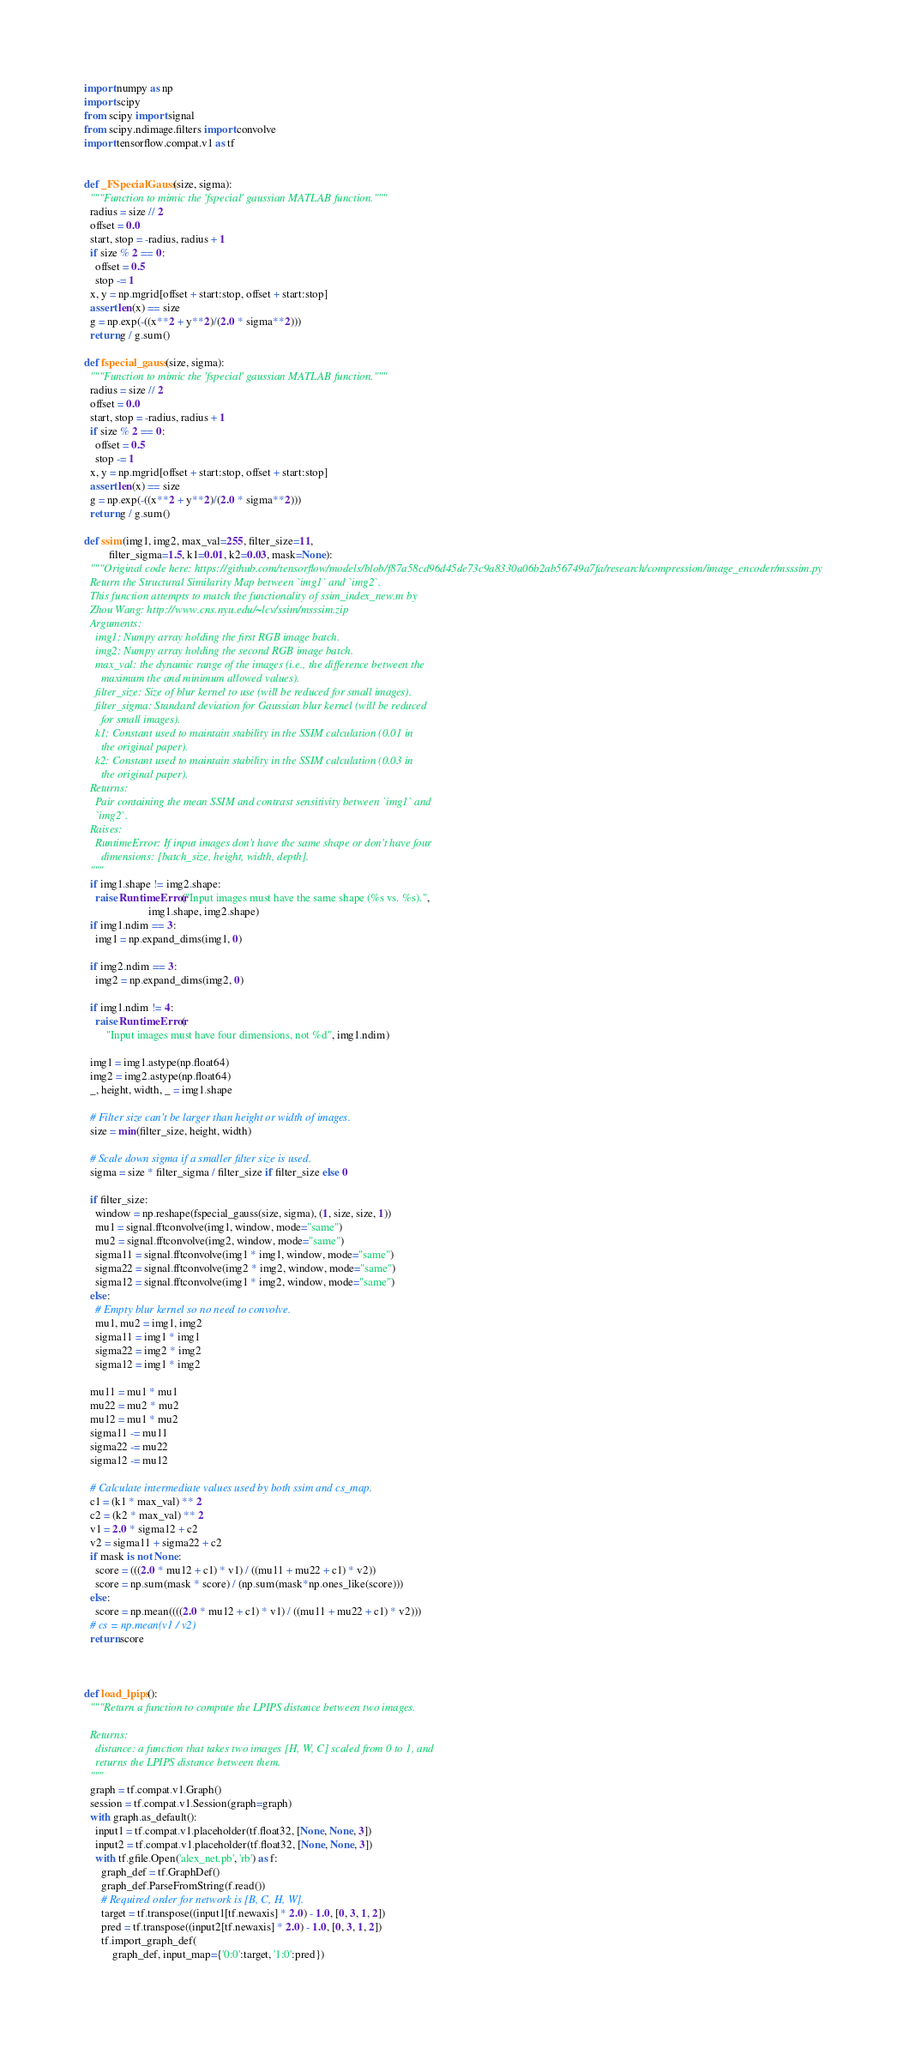Convert code to text. <code><loc_0><loc_0><loc_500><loc_500><_Python_>
import numpy as np
import scipy
from scipy import signal
from scipy.ndimage.filters import convolve
import tensorflow.compat.v1 as tf


def _FSpecialGauss(size, sigma):
  """Function to mimic the 'fspecial' gaussian MATLAB function."""
  radius = size // 2
  offset = 0.0
  start, stop = -radius, radius + 1
  if size % 2 == 0:
    offset = 0.5
    stop -= 1
  x, y = np.mgrid[offset + start:stop, offset + start:stop]
  assert len(x) == size
  g = np.exp(-((x**2 + y**2)/(2.0 * sigma**2)))
  return g / g.sum()

def fspecial_gauss(size, sigma):
  """Function to mimic the 'fspecial' gaussian MATLAB function."""
  radius = size // 2
  offset = 0.0
  start, stop = -radius, radius + 1
  if size % 2 == 0:
    offset = 0.5
    stop -= 1
  x, y = np.mgrid[offset + start:stop, offset + start:stop]
  assert len(x) == size
  g = np.exp(-((x**2 + y**2)/(2.0 * sigma**2)))
  return g / g.sum()

def ssim(img1, img2, max_val=255, filter_size=11,
         filter_sigma=1.5, k1=0.01, k2=0.03, mask=None):
  """Original code here: https://github.com/tensorflow/models/blob/f87a58cd96d45de73c9a8330a06b2ab56749a7fa/research/compression/image_encoder/msssim.py
  Return the Structural Similarity Map between `img1` and `img2`.
  This function attempts to match the functionality of ssim_index_new.m by
  Zhou Wang: http://www.cns.nyu.edu/~lcv/ssim/msssim.zip
  Arguments:
    img1: Numpy array holding the first RGB image batch.
    img2: Numpy array holding the second RGB image batch.
    max_val: the dynamic range of the images (i.e., the difference between the
      maximum the and minimum allowed values).
    filter_size: Size of blur kernel to use (will be reduced for small images).
    filter_sigma: Standard deviation for Gaussian blur kernel (will be reduced
      for small images).
    k1: Constant used to maintain stability in the SSIM calculation (0.01 in
      the original paper).
    k2: Constant used to maintain stability in the SSIM calculation (0.03 in
      the original paper).
  Returns:
    Pair containing the mean SSIM and contrast sensitivity between `img1` and
    `img2`.
  Raises:
    RuntimeError: If input images don't have the same shape or don't have four
      dimensions: [batch_size, height, width, depth].
  """
  if img1.shape != img2.shape:
    raise RuntimeError("Input images must have the same shape (%s vs. %s).",
                       img1.shape, img2.shape)
  if img1.ndim == 3:
    img1 = np.expand_dims(img1, 0)

  if img2.ndim == 3:
    img2 = np.expand_dims(img2, 0)

  if img1.ndim != 4:
    raise RuntimeError(
        "Input images must have four dimensions, not %d", img1.ndim)

  img1 = img1.astype(np.float64)
  img2 = img2.astype(np.float64)
  _, height, width, _ = img1.shape

  # Filter size can't be larger than height or width of images.
  size = min(filter_size, height, width)

  # Scale down sigma if a smaller filter size is used.
  sigma = size * filter_sigma / filter_size if filter_size else 0

  if filter_size:
    window = np.reshape(fspecial_gauss(size, sigma), (1, size, size, 1))
    mu1 = signal.fftconvolve(img1, window, mode="same")
    mu2 = signal.fftconvolve(img2, window, mode="same")
    sigma11 = signal.fftconvolve(img1 * img1, window, mode="same")
    sigma22 = signal.fftconvolve(img2 * img2, window, mode="same")
    sigma12 = signal.fftconvolve(img1 * img2, window, mode="same")
  else:
    # Empty blur kernel so no need to convolve.
    mu1, mu2 = img1, img2
    sigma11 = img1 * img1
    sigma22 = img2 * img2
    sigma12 = img1 * img2

  mu11 = mu1 * mu1
  mu22 = mu2 * mu2
  mu12 = mu1 * mu2
  sigma11 -= mu11
  sigma22 -= mu22
  sigma12 -= mu12

  # Calculate intermediate values used by both ssim and cs_map.
  c1 = (k1 * max_val) ** 2
  c2 = (k2 * max_val) ** 2
  v1 = 2.0 * sigma12 + c2
  v2 = sigma11 + sigma22 + c2
  if mask is not None:
    score = (((2.0 * mu12 + c1) * v1) / ((mu11 + mu22 + c1) * v2))
    score = np.sum(mask * score) / (np.sum(mask*np.ones_like(score)))
  else:
    score = np.mean((((2.0 * mu12 + c1) * v1) / ((mu11 + mu22 + c1) * v2)))
  # cs = np.mean(v1 / v2)
  return score



def load_lpips():
  """Return a function to compute the LPIPS distance between two images.

  Returns:
    distance: a function that takes two images [H, W, C] scaled from 0 to 1, and
    returns the LPIPS distance between them.
  """
  graph = tf.compat.v1.Graph()
  session = tf.compat.v1.Session(graph=graph)
  with graph.as_default():
    input1 = tf.compat.v1.placeholder(tf.float32, [None, None, 3])
    input2 = tf.compat.v1.placeholder(tf.float32, [None, None, 3])
    with tf.gfile.Open('alex_net.pb', 'rb') as f:
      graph_def = tf.GraphDef()
      graph_def.ParseFromString(f.read())
      # Required order for network is [B, C, H, W].
      target = tf.transpose((input1[tf.newaxis] * 2.0) - 1.0, [0, 3, 1, 2])
      pred = tf.transpose((input2[tf.newaxis] * 2.0) - 1.0, [0, 3, 1, 2])
      tf.import_graph_def(
          graph_def, input_map={'0:0':target, '1:0':pred})</code> 